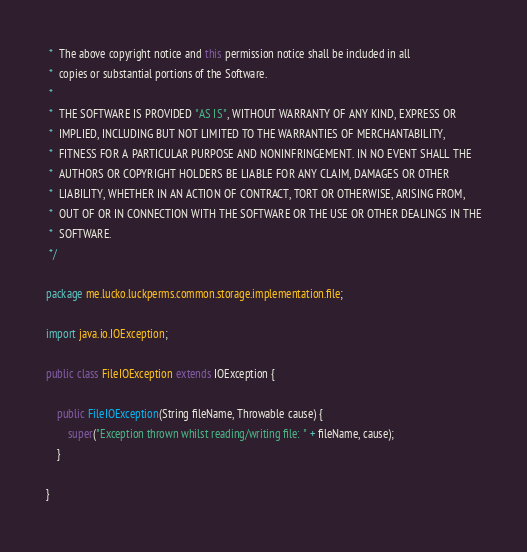Convert code to text. <code><loc_0><loc_0><loc_500><loc_500><_Java_> *  The above copyright notice and this permission notice shall be included in all
 *  copies or substantial portions of the Software.
 *
 *  THE SOFTWARE IS PROVIDED "AS IS", WITHOUT WARRANTY OF ANY KIND, EXPRESS OR
 *  IMPLIED, INCLUDING BUT NOT LIMITED TO THE WARRANTIES OF MERCHANTABILITY,
 *  FITNESS FOR A PARTICULAR PURPOSE AND NONINFRINGEMENT. IN NO EVENT SHALL THE
 *  AUTHORS OR COPYRIGHT HOLDERS BE LIABLE FOR ANY CLAIM, DAMAGES OR OTHER
 *  LIABILITY, WHETHER IN AN ACTION OF CONTRACT, TORT OR OTHERWISE, ARISING FROM,
 *  OUT OF OR IN CONNECTION WITH THE SOFTWARE OR THE USE OR OTHER DEALINGS IN THE
 *  SOFTWARE.
 */

package me.lucko.luckperms.common.storage.implementation.file;

import java.io.IOException;

public class FileIOException extends IOException {

    public FileIOException(String fileName, Throwable cause) {
        super("Exception thrown whilst reading/writing file: " + fileName, cause);
    }

}
</code> 